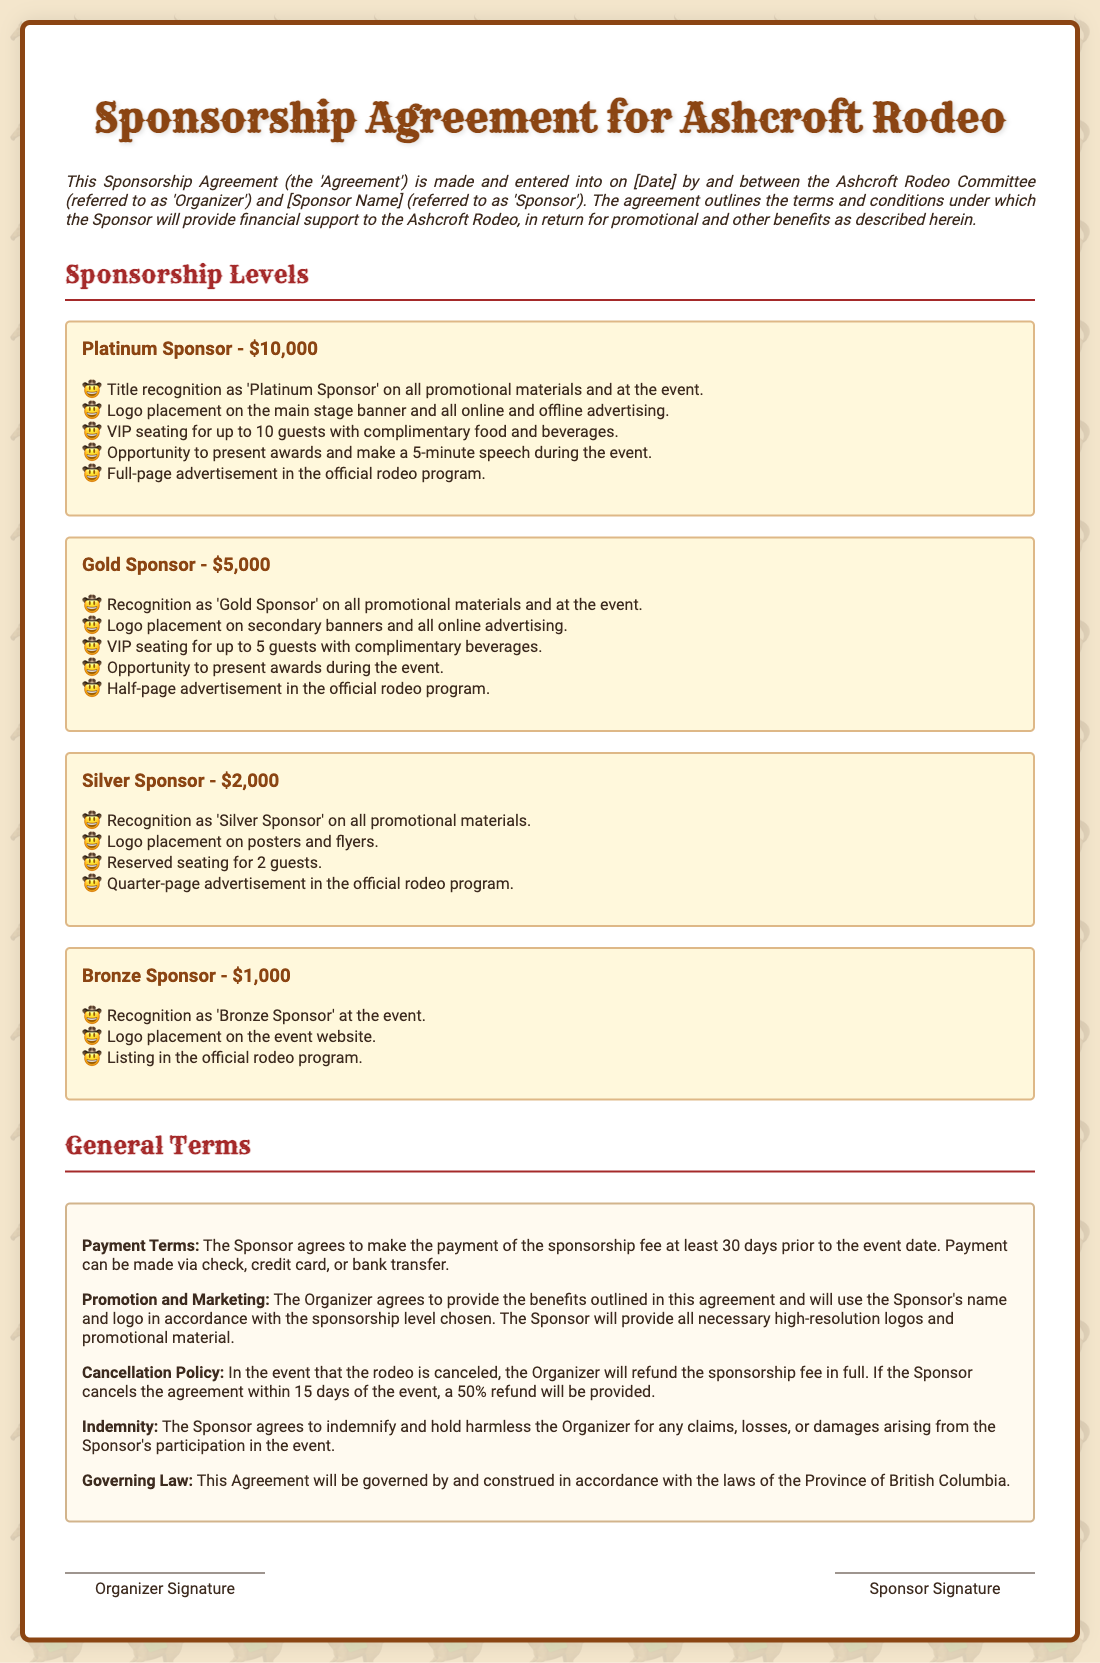What date should the sponsorship fee be paid? The payment of the sponsorship fee must be made at least 30 days prior to the event date.
Answer: 30 days prior What is the amount for a Platinum sponsorship? The Platinum sponsorship is listed in the document, reflecting the total financial commitment.
Answer: $10,000 What recognition does a Silver Sponsor receive? The recognition included for Silver Sponsors is specified in the benefits listed under their section.
Answer: Silver Sponsor How many guests receive VIP seating under the Gold Sponsorship? The document quantifies the number of guests that can sit in VIP seating under Gold Sponsor benefits.
Answer: 5 guests What is included in the Bronze Sponsor listing? Details regarding the benefits allocated to Bronze Sponsors indicate specific acknowledgments.
Answer: Listing in the official rodeo program What type of advertisement does a Gold Sponsor receive? The document specifies the size and type of advertisement associated with Gold Sponsorship.
Answer: Half-page advertisement What happens if the rodeo is canceled? The cancellation policy details actions regarding refunds in the case of event cancellation.
Answer: Refund sponsorship fee in full Who governs the Sponsorship Agreement? The document outlines which jurisdiction's laws will apply to the agreement.
Answer: Province of British Columbia 